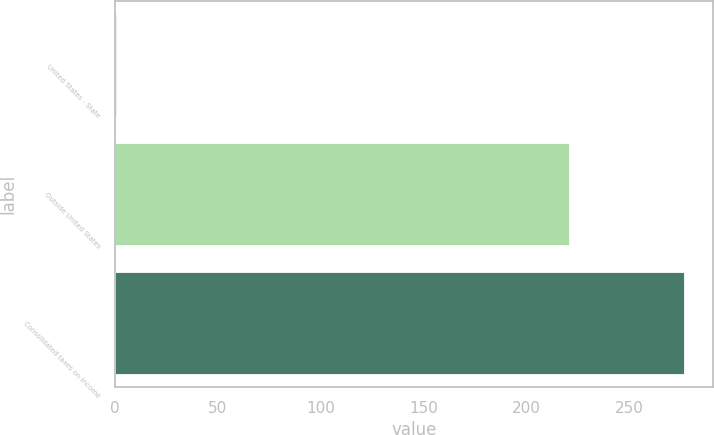Convert chart to OTSL. <chart><loc_0><loc_0><loc_500><loc_500><bar_chart><fcel>United States - State<fcel>Outside United States<fcel>Consolidated taxes on income<nl><fcel>1<fcel>221<fcel>277<nl></chart> 